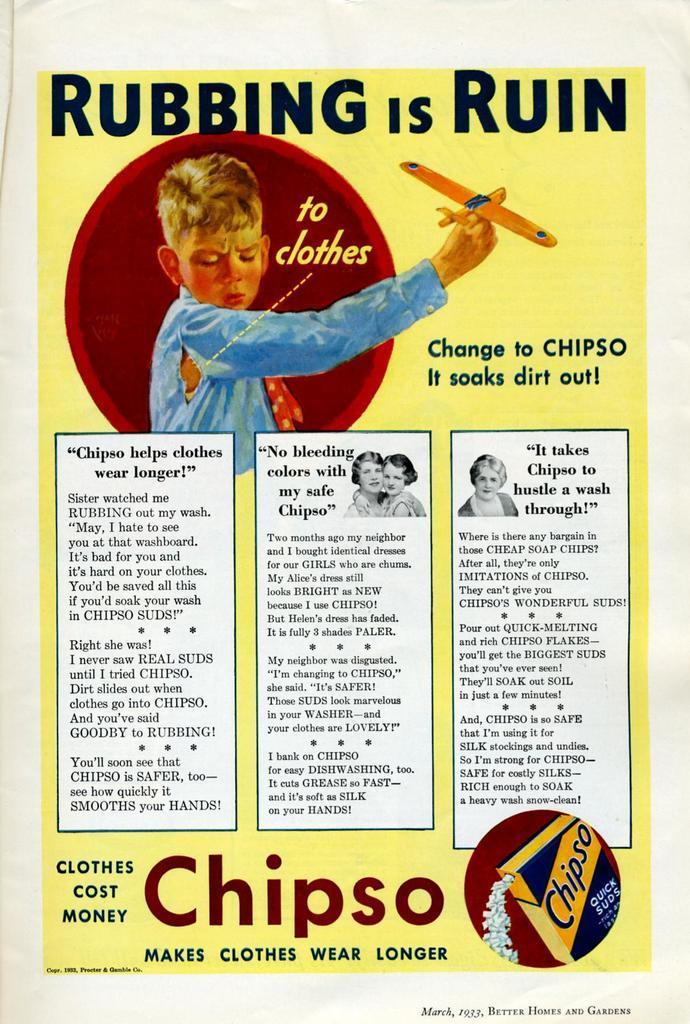<image>
Provide a brief description of the given image. A vintage advertisement that reads RUBBING IS RUIN. 